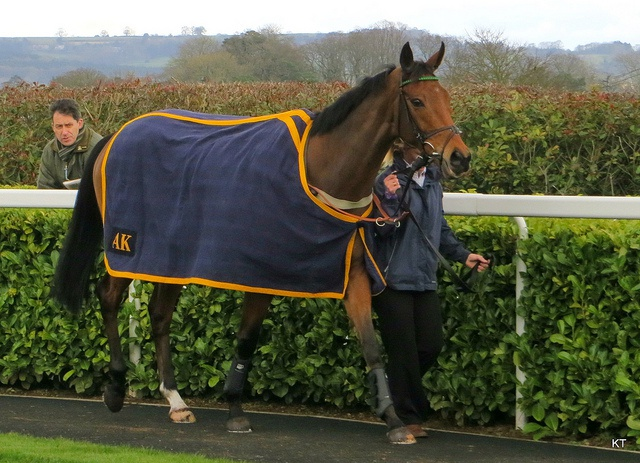Describe the objects in this image and their specific colors. I can see horse in white, black, gray, and olive tones, people in white, black, and gray tones, and people in white, gray, darkgreen, black, and tan tones in this image. 